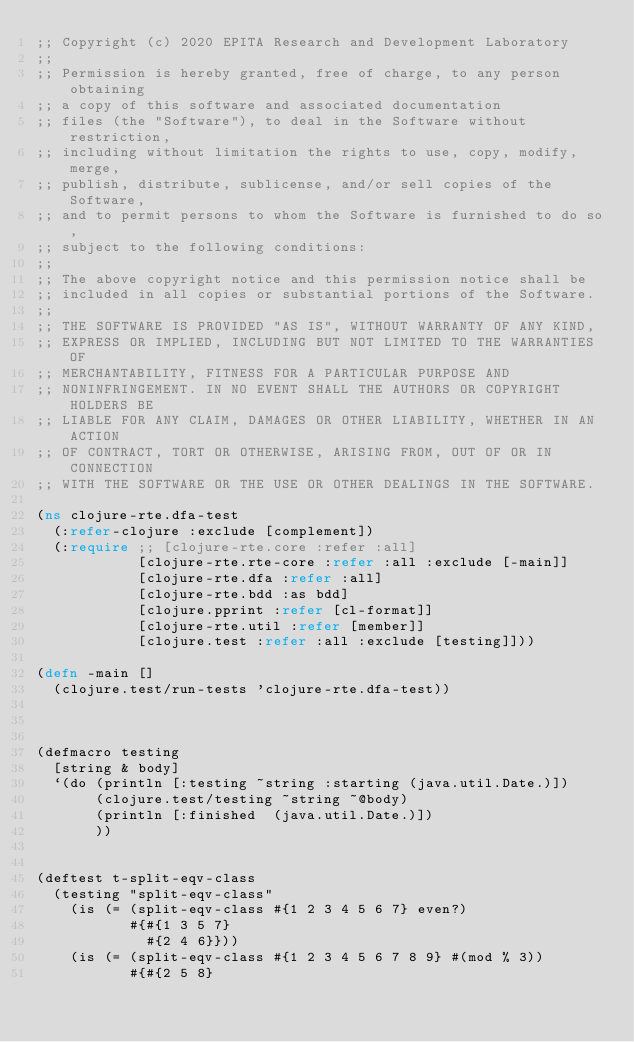Convert code to text. <code><loc_0><loc_0><loc_500><loc_500><_Clojure_>;; Copyright (c) 2020 EPITA Research and Development Laboratory
;;
;; Permission is hereby granted, free of charge, to any person obtaining
;; a copy of this software and associated documentation
;; files (the "Software"), to deal in the Software without restriction,
;; including without limitation the rights to use, copy, modify, merge,
;; publish, distribute, sublicense, and/or sell copies of the Software,
;; and to permit persons to whom the Software is furnished to do so,
;; subject to the following conditions:
;;
;; The above copyright notice and this permission notice shall be
;; included in all copies or substantial portions of the Software.
;;
;; THE SOFTWARE IS PROVIDED "AS IS", WITHOUT WARRANTY OF ANY KIND,
;; EXPRESS OR IMPLIED, INCLUDING BUT NOT LIMITED TO THE WARRANTIES OF
;; MERCHANTABILITY, FITNESS FOR A PARTICULAR PURPOSE AND
;; NONINFRINGEMENT. IN NO EVENT SHALL THE AUTHORS OR COPYRIGHT HOLDERS BE
;; LIABLE FOR ANY CLAIM, DAMAGES OR OTHER LIABILITY, WHETHER IN AN ACTION
;; OF CONTRACT, TORT OR OTHERWISE, ARISING FROM, OUT OF OR IN CONNECTION
;; WITH THE SOFTWARE OR THE USE OR OTHER DEALINGS IN THE SOFTWARE.

(ns clojure-rte.dfa-test
  (:refer-clojure :exclude [complement])
  (:require ;; [clojure-rte.core :refer :all]
            [clojure-rte.rte-core :refer :all :exclude [-main]]
            [clojure-rte.dfa :refer :all]
            [clojure-rte.bdd :as bdd]
            [clojure.pprint :refer [cl-format]]
            [clojure-rte.util :refer [member]]
            [clojure.test :refer :all :exclude [testing]]))

(defn -main []
  (clojure.test/run-tests 'clojure-rte.dfa-test))



(defmacro testing
  [string & body]
  `(do (println [:testing ~string :starting (java.util.Date.)])
       (clojure.test/testing ~string ~@body)
       (println [:finished  (java.util.Date.)])
       ))


(deftest t-split-eqv-class
  (testing "split-eqv-class"
    (is (= (split-eqv-class #{1 2 3 4 5 6 7} even?)
           #{#{1 3 5 7}
             #{2 4 6}}))
    (is (= (split-eqv-class #{1 2 3 4 5 6 7 8 9} #(mod % 3))
           #{#{2 5 8}</code> 